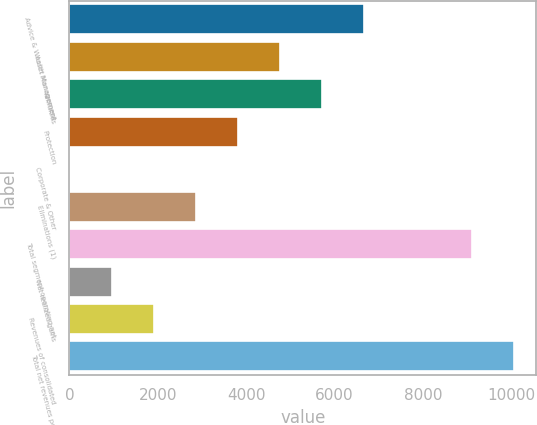Convert chart to OTSL. <chart><loc_0><loc_0><loc_500><loc_500><bar_chart><fcel>Advice & Wealth Management<fcel>Asset Management<fcel>Annuities<fcel>Protection<fcel>Corporate & Other<fcel>Eliminations (1)<fcel>Total segment operating net<fcel>Net realized gains<fcel>Revenues of consolidated<fcel>Total net revenues per<nl><fcel>6659.6<fcel>4758<fcel>5708.8<fcel>3807.2<fcel>4<fcel>2856.4<fcel>9117<fcel>954.8<fcel>1905.6<fcel>10067.8<nl></chart> 